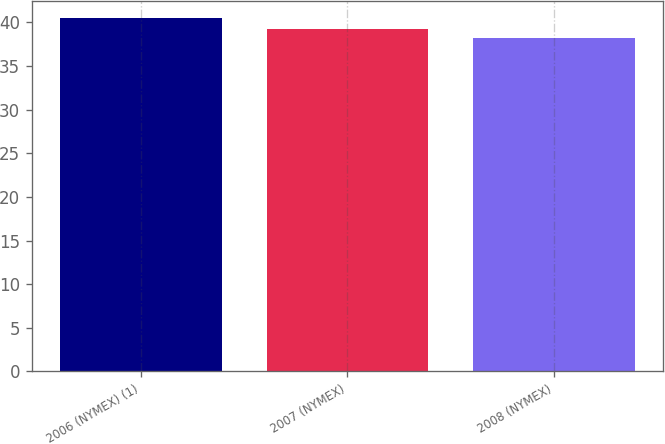Convert chart. <chart><loc_0><loc_0><loc_500><loc_500><bar_chart><fcel>2006 (NYMEX) (1)<fcel>2007 (NYMEX)<fcel>2008 (NYMEX)<nl><fcel>40.47<fcel>39.19<fcel>38.23<nl></chart> 